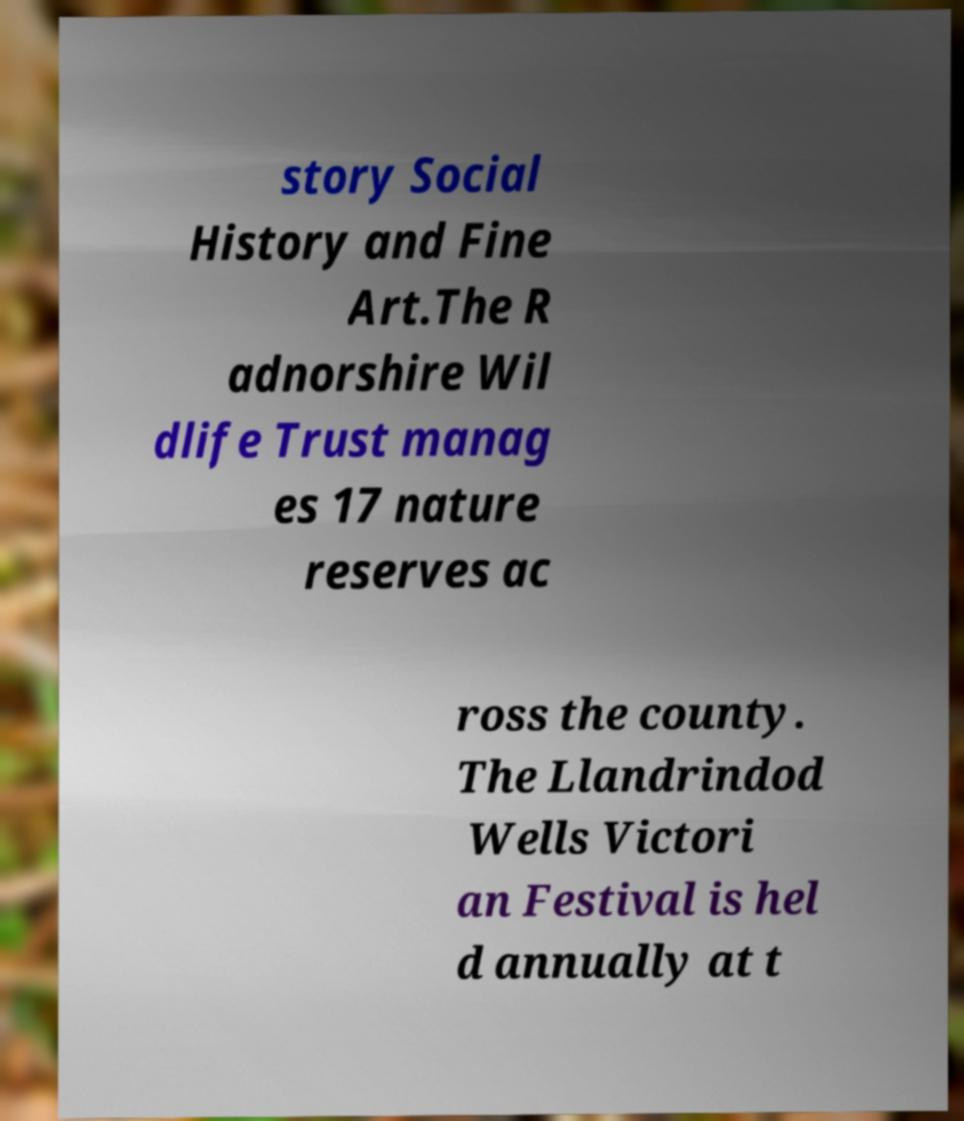Please read and relay the text visible in this image. What does it say? story Social History and Fine Art.The R adnorshire Wil dlife Trust manag es 17 nature reserves ac ross the county. The Llandrindod Wells Victori an Festival is hel d annually at t 